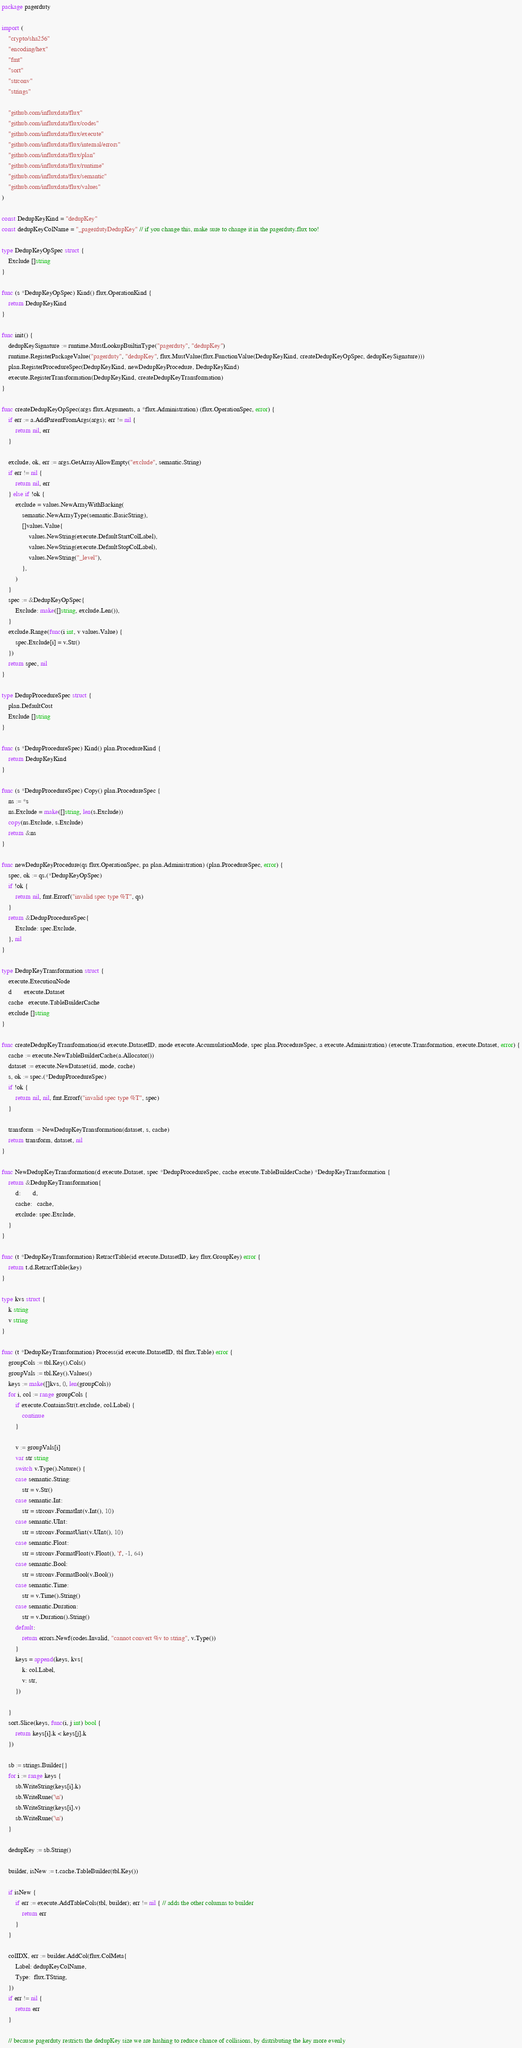<code> <loc_0><loc_0><loc_500><loc_500><_Go_>package pagerduty

import (
	"crypto/sha256"
	"encoding/hex"
	"fmt"
	"sort"
	"strconv"
	"strings"

	"github.com/influxdata/flux"
	"github.com/influxdata/flux/codes"
	"github.com/influxdata/flux/execute"
	"github.com/influxdata/flux/internal/errors"
	"github.com/influxdata/flux/plan"
	"github.com/influxdata/flux/runtime"
	"github.com/influxdata/flux/semantic"
	"github.com/influxdata/flux/values"
)

const DedupKeyKind = "dedupKey"
const dedupKeyColName = "_pagerdutyDedupKey" // if you change this, make sure to change it in the pagerduty.flux too!

type DedupKeyOpSpec struct {
	Exclude []string
}

func (s *DedupKeyOpSpec) Kind() flux.OperationKind {
	return DedupKeyKind
}

func init() {
	dedupKeySignature := runtime.MustLookupBuiltinType("pagerduty", "dedupKey")
	runtime.RegisterPackageValue("pagerduty", "dedupKey", flux.MustValue(flux.FunctionValue(DedupKeyKind, createDedupKeyOpSpec, dedupKeySignature)))
	plan.RegisterProcedureSpec(DedupKeyKind, newDedupKeyProcedure, DedupKeyKind)
	execute.RegisterTransformation(DedupKeyKind, createDedupKeyTransformation)
}

func createDedupKeyOpSpec(args flux.Arguments, a *flux.Administration) (flux.OperationSpec, error) {
	if err := a.AddParentFromArgs(args); err != nil {
		return nil, err
	}

	exclude, ok, err := args.GetArrayAllowEmpty("exclude", semantic.String)
	if err != nil {
		return nil, err
	} else if !ok {
		exclude = values.NewArrayWithBacking(
			semantic.NewArrayType(semantic.BasicString),
			[]values.Value{
				values.NewString(execute.DefaultStartColLabel),
				values.NewString(execute.DefaultStopColLabel),
				values.NewString("_level"),
			},
		)
	}
	spec := &DedupKeyOpSpec{
		Exclude: make([]string, exclude.Len()),
	}
	exclude.Range(func(i int, v values.Value) {
		spec.Exclude[i] = v.Str()
	})
	return spec, nil
}

type DedupProcedureSpec struct {
	plan.DefaultCost
	Exclude []string
}

func (s *DedupProcedureSpec) Kind() plan.ProcedureKind {
	return DedupKeyKind
}

func (s *DedupProcedureSpec) Copy() plan.ProcedureSpec {
	ns := *s
	ns.Exclude = make([]string, len(s.Exclude))
	copy(ns.Exclude, s.Exclude)
	return &ns
}

func newDedupKeyProcedure(qs flux.OperationSpec, pa plan.Administration) (plan.ProcedureSpec, error) {
	spec, ok := qs.(*DedupKeyOpSpec)
	if !ok {
		return nil, fmt.Errorf("invalid spec type %T", qs)
	}
	return &DedupProcedureSpec{
		Exclude: spec.Exclude,
	}, nil
}

type DedupKeyTransformation struct {
	execute.ExecutionNode
	d       execute.Dataset
	cache   execute.TableBuilderCache
	exclude []string
}

func createDedupKeyTransformation(id execute.DatasetID, mode execute.AccumulationMode, spec plan.ProcedureSpec, a execute.Administration) (execute.Transformation, execute.Dataset, error) {
	cache := execute.NewTableBuilderCache(a.Allocator())
	dataset := execute.NewDataset(id, mode, cache)
	s, ok := spec.(*DedupProcedureSpec)
	if !ok {
		return nil, nil, fmt.Errorf("invalid spec type %T", spec)
	}

	transform := NewDedupKeyTransformation(dataset, s, cache)
	return transform, dataset, nil
}

func NewDedupKeyTransformation(d execute.Dataset, spec *DedupProcedureSpec, cache execute.TableBuilderCache) *DedupKeyTransformation {
	return &DedupKeyTransformation{
		d:       d,
		cache:   cache,
		exclude: spec.Exclude,
	}
}

func (t *DedupKeyTransformation) RetractTable(id execute.DatasetID, key flux.GroupKey) error {
	return t.d.RetractTable(key)
}

type kvs struct {
	k string
	v string
}

func (t *DedupKeyTransformation) Process(id execute.DatasetID, tbl flux.Table) error {
	groupCols := tbl.Key().Cols()
	groupVals := tbl.Key().Values()
	keys := make([]kvs, 0, len(groupCols))
	for i, col := range groupCols {
		if execute.ContainsStr(t.exclude, col.Label) {
			continue
		}

		v := groupVals[i]
		var str string
		switch v.Type().Nature() {
		case semantic.String:
			str = v.Str()
		case semantic.Int:
			str = strconv.FormatInt(v.Int(), 10)
		case semantic.UInt:
			str = strconv.FormatUint(v.UInt(), 10)
		case semantic.Float:
			str = strconv.FormatFloat(v.Float(), 'f', -1, 64)
		case semantic.Bool:
			str = strconv.FormatBool(v.Bool())
		case semantic.Time:
			str = v.Time().String()
		case semantic.Duration:
			str = v.Duration().String()
		default:
			return errors.Newf(codes.Invalid, "cannot convert %v to string", v.Type())
		}
		keys = append(keys, kvs{
			k: col.Label,
			v: str,
		})

	}
	sort.Slice(keys, func(i, j int) bool {
		return keys[i].k < keys[j].k
	})

	sb := strings.Builder{}
	for i := range keys {
		sb.WriteString(keys[i].k)
		sb.WriteRune('\n')
		sb.WriteString(keys[i].v)
		sb.WriteRune('\n')
	}

	dedupKey := sb.String()

	builder, isNew := t.cache.TableBuilder(tbl.Key())

	if isNew {
		if err := execute.AddTableCols(tbl, builder); err != nil { // adds the other columns to builder
			return err
		}
	}

	colIDX, err := builder.AddCol(flux.ColMeta{
		Label: dedupKeyColName,
		Type:  flux.TString,
	})
	if err != nil {
		return err
	}

	// because pagerduty restricts the dedupKey size we are hashing to reduce chance of collisions, by distributing the key more evenly</code> 